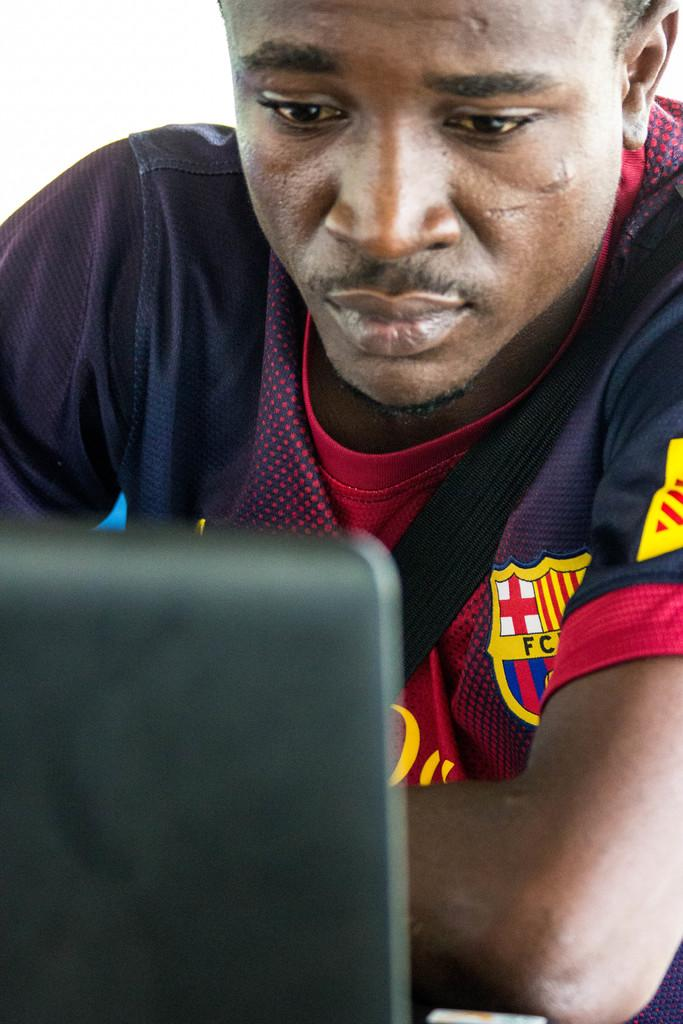<image>
Describe the image concisely. A man looks at a laptop while wearing a shirt on which the letters F and C are on the left chest. 